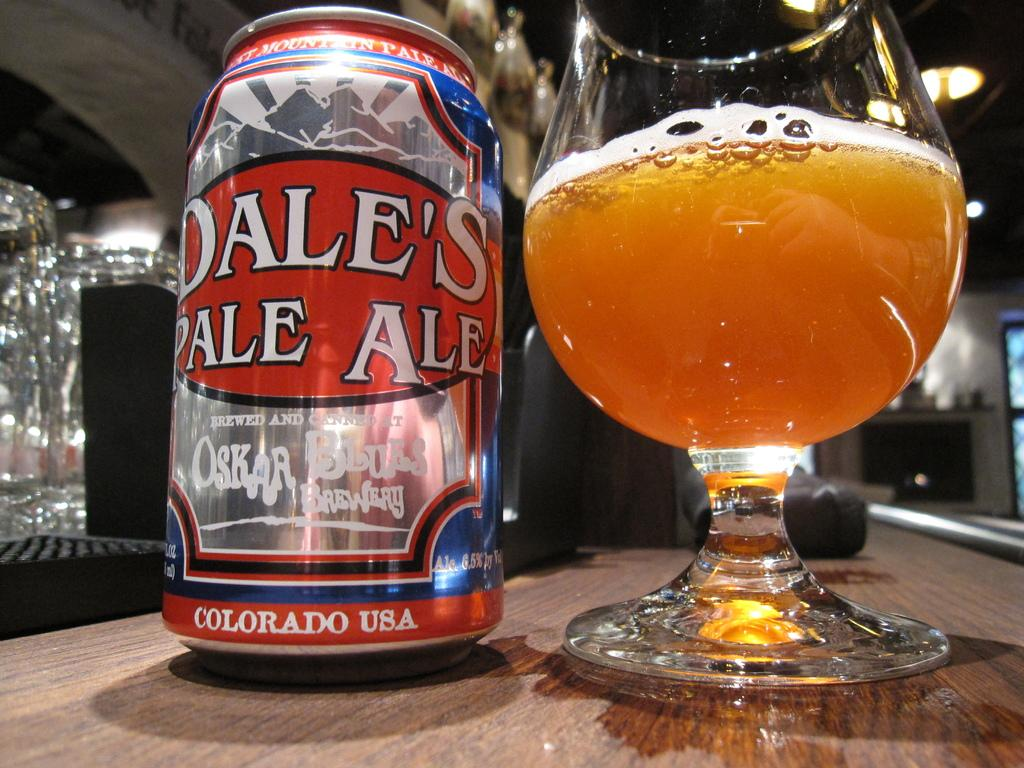<image>
Summarize the visual content of the image. Cup of beer next to a can that says COLORADO USA near the bottom. 